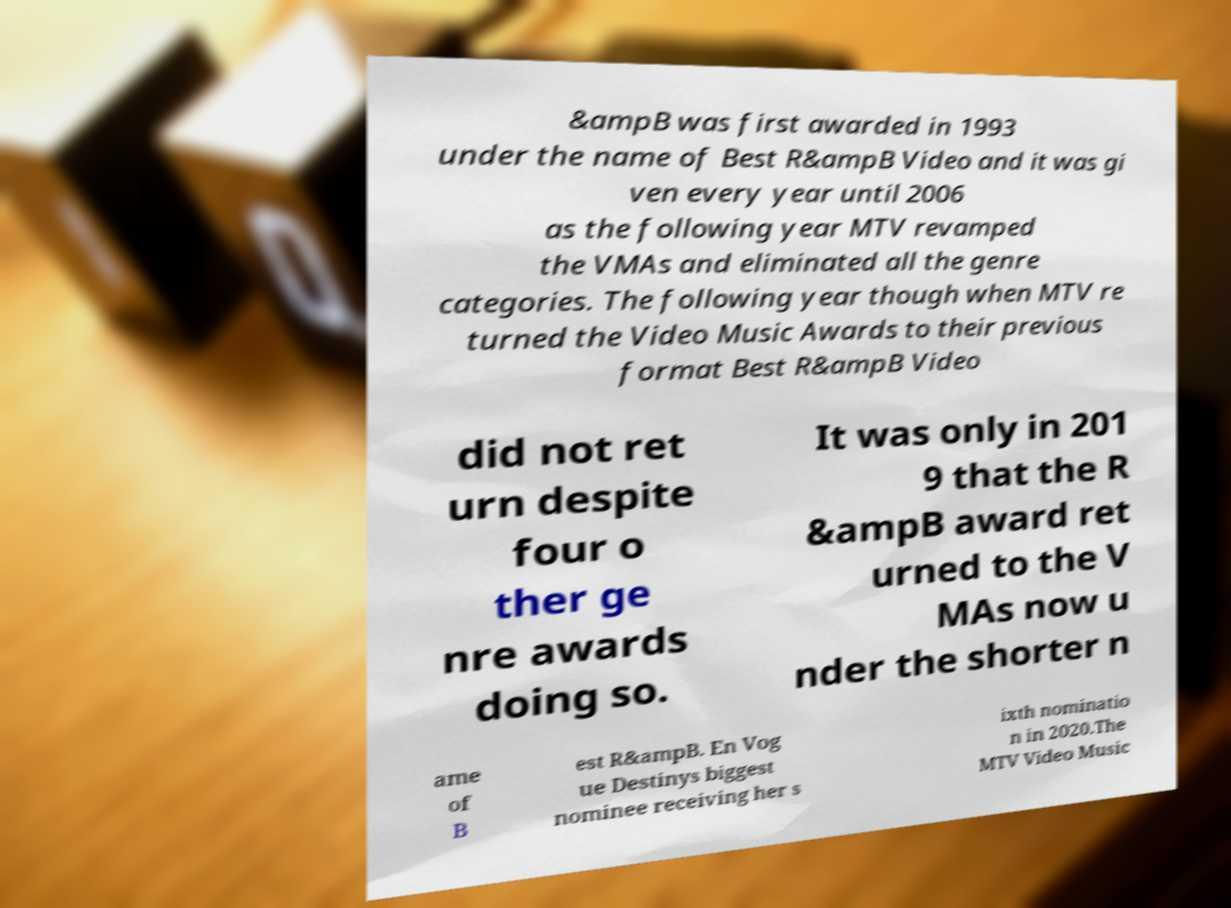Can you read and provide the text displayed in the image?This photo seems to have some interesting text. Can you extract and type it out for me? &ampB was first awarded in 1993 under the name of Best R&ampB Video and it was gi ven every year until 2006 as the following year MTV revamped the VMAs and eliminated all the genre categories. The following year though when MTV re turned the Video Music Awards to their previous format Best R&ampB Video did not ret urn despite four o ther ge nre awards doing so. It was only in 201 9 that the R &ampB award ret urned to the V MAs now u nder the shorter n ame of B est R&ampB. En Vog ue Destinys biggest nominee receiving her s ixth nominatio n in 2020.The MTV Video Music 